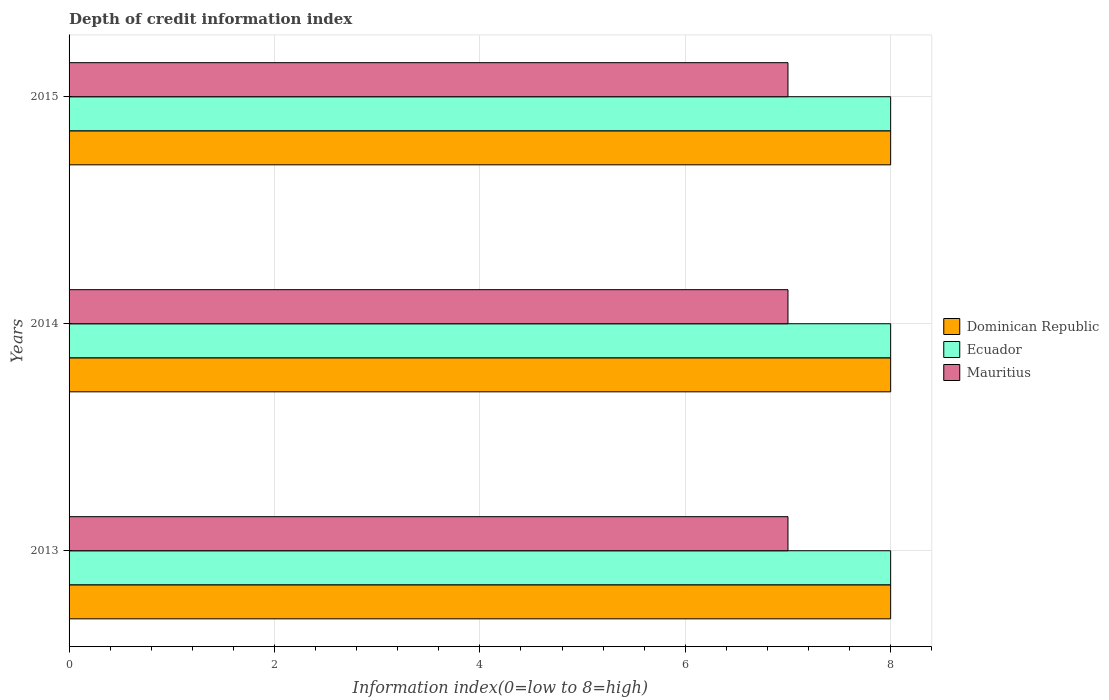How many different coloured bars are there?
Offer a terse response. 3. Are the number of bars on each tick of the Y-axis equal?
Your answer should be compact. Yes. How many bars are there on the 3rd tick from the top?
Offer a terse response. 3. How many bars are there on the 1st tick from the bottom?
Make the answer very short. 3. In how many cases, is the number of bars for a given year not equal to the number of legend labels?
Provide a short and direct response. 0. What is the information index in Ecuador in 2015?
Offer a very short reply. 8. Across all years, what is the maximum information index in Ecuador?
Your answer should be very brief. 8. Across all years, what is the minimum information index in Dominican Republic?
Provide a short and direct response. 8. In which year was the information index in Dominican Republic maximum?
Give a very brief answer. 2013. What is the total information index in Dominican Republic in the graph?
Your answer should be very brief. 24. What is the difference between the information index in Ecuador in 2013 and that in 2014?
Provide a succinct answer. 0. In the year 2013, what is the difference between the information index in Dominican Republic and information index in Ecuador?
Make the answer very short. 0. Is the information index in Ecuador in 2013 less than that in 2014?
Offer a terse response. No. What does the 1st bar from the top in 2014 represents?
Your answer should be compact. Mauritius. What does the 2nd bar from the bottom in 2013 represents?
Ensure brevity in your answer.  Ecuador. Is it the case that in every year, the sum of the information index in Mauritius and information index in Dominican Republic is greater than the information index in Ecuador?
Offer a terse response. Yes. How many bars are there?
Keep it short and to the point. 9. How many years are there in the graph?
Offer a very short reply. 3. Does the graph contain grids?
Keep it short and to the point. Yes. Where does the legend appear in the graph?
Give a very brief answer. Center right. How many legend labels are there?
Keep it short and to the point. 3. How are the legend labels stacked?
Keep it short and to the point. Vertical. What is the title of the graph?
Make the answer very short. Depth of credit information index. Does "Hong Kong" appear as one of the legend labels in the graph?
Your answer should be compact. No. What is the label or title of the X-axis?
Make the answer very short. Information index(0=low to 8=high). What is the label or title of the Y-axis?
Keep it short and to the point. Years. What is the Information index(0=low to 8=high) of Ecuador in 2013?
Ensure brevity in your answer.  8. What is the Information index(0=low to 8=high) of Mauritius in 2013?
Keep it short and to the point. 7. What is the Information index(0=low to 8=high) of Ecuador in 2014?
Your answer should be compact. 8. What is the Information index(0=low to 8=high) in Mauritius in 2014?
Ensure brevity in your answer.  7. What is the Information index(0=low to 8=high) in Mauritius in 2015?
Offer a very short reply. 7. Across all years, what is the maximum Information index(0=low to 8=high) of Mauritius?
Ensure brevity in your answer.  7. Across all years, what is the minimum Information index(0=low to 8=high) of Dominican Republic?
Your answer should be compact. 8. What is the total Information index(0=low to 8=high) of Dominican Republic in the graph?
Your answer should be compact. 24. What is the total Information index(0=low to 8=high) of Ecuador in the graph?
Offer a very short reply. 24. What is the difference between the Information index(0=low to 8=high) of Dominican Republic in 2013 and that in 2014?
Offer a very short reply. 0. What is the difference between the Information index(0=low to 8=high) of Mauritius in 2013 and that in 2014?
Provide a short and direct response. 0. What is the difference between the Information index(0=low to 8=high) of Dominican Republic in 2013 and that in 2015?
Your response must be concise. 0. What is the difference between the Information index(0=low to 8=high) in Mauritius in 2013 and that in 2015?
Your response must be concise. 0. What is the difference between the Information index(0=low to 8=high) of Dominican Republic in 2014 and that in 2015?
Your answer should be compact. 0. What is the difference between the Information index(0=low to 8=high) in Ecuador in 2014 and that in 2015?
Provide a succinct answer. 0. What is the difference between the Information index(0=low to 8=high) in Dominican Republic in 2013 and the Information index(0=low to 8=high) in Mauritius in 2014?
Ensure brevity in your answer.  1. What is the difference between the Information index(0=low to 8=high) in Ecuador in 2013 and the Information index(0=low to 8=high) in Mauritius in 2014?
Provide a short and direct response. 1. What is the difference between the Information index(0=low to 8=high) in Dominican Republic in 2013 and the Information index(0=low to 8=high) in Ecuador in 2015?
Give a very brief answer. 0. What is the difference between the Information index(0=low to 8=high) in Dominican Republic in 2013 and the Information index(0=low to 8=high) in Mauritius in 2015?
Your response must be concise. 1. What is the difference between the Information index(0=low to 8=high) of Dominican Republic in 2014 and the Information index(0=low to 8=high) of Ecuador in 2015?
Keep it short and to the point. 0. What is the difference between the Information index(0=low to 8=high) of Ecuador in 2014 and the Information index(0=low to 8=high) of Mauritius in 2015?
Your answer should be compact. 1. What is the average Information index(0=low to 8=high) of Dominican Republic per year?
Provide a succinct answer. 8. What is the average Information index(0=low to 8=high) of Ecuador per year?
Give a very brief answer. 8. What is the average Information index(0=low to 8=high) in Mauritius per year?
Make the answer very short. 7. In the year 2013, what is the difference between the Information index(0=low to 8=high) in Dominican Republic and Information index(0=low to 8=high) in Ecuador?
Ensure brevity in your answer.  0. In the year 2013, what is the difference between the Information index(0=low to 8=high) in Dominican Republic and Information index(0=low to 8=high) in Mauritius?
Your answer should be very brief. 1. In the year 2014, what is the difference between the Information index(0=low to 8=high) in Dominican Republic and Information index(0=low to 8=high) in Ecuador?
Give a very brief answer. 0. In the year 2015, what is the difference between the Information index(0=low to 8=high) in Dominican Republic and Information index(0=low to 8=high) in Ecuador?
Offer a very short reply. 0. In the year 2015, what is the difference between the Information index(0=low to 8=high) in Dominican Republic and Information index(0=low to 8=high) in Mauritius?
Your answer should be very brief. 1. What is the ratio of the Information index(0=low to 8=high) in Ecuador in 2013 to that in 2014?
Your answer should be compact. 1. What is the ratio of the Information index(0=low to 8=high) in Mauritius in 2013 to that in 2014?
Ensure brevity in your answer.  1. What is the ratio of the Information index(0=low to 8=high) in Dominican Republic in 2013 to that in 2015?
Give a very brief answer. 1. What is the ratio of the Information index(0=low to 8=high) of Ecuador in 2013 to that in 2015?
Offer a terse response. 1. What is the ratio of the Information index(0=low to 8=high) of Mauritius in 2013 to that in 2015?
Your response must be concise. 1. What is the difference between the highest and the second highest Information index(0=low to 8=high) in Dominican Republic?
Your answer should be compact. 0. What is the difference between the highest and the second highest Information index(0=low to 8=high) in Mauritius?
Keep it short and to the point. 0. What is the difference between the highest and the lowest Information index(0=low to 8=high) of Dominican Republic?
Ensure brevity in your answer.  0. What is the difference between the highest and the lowest Information index(0=low to 8=high) in Ecuador?
Keep it short and to the point. 0. 